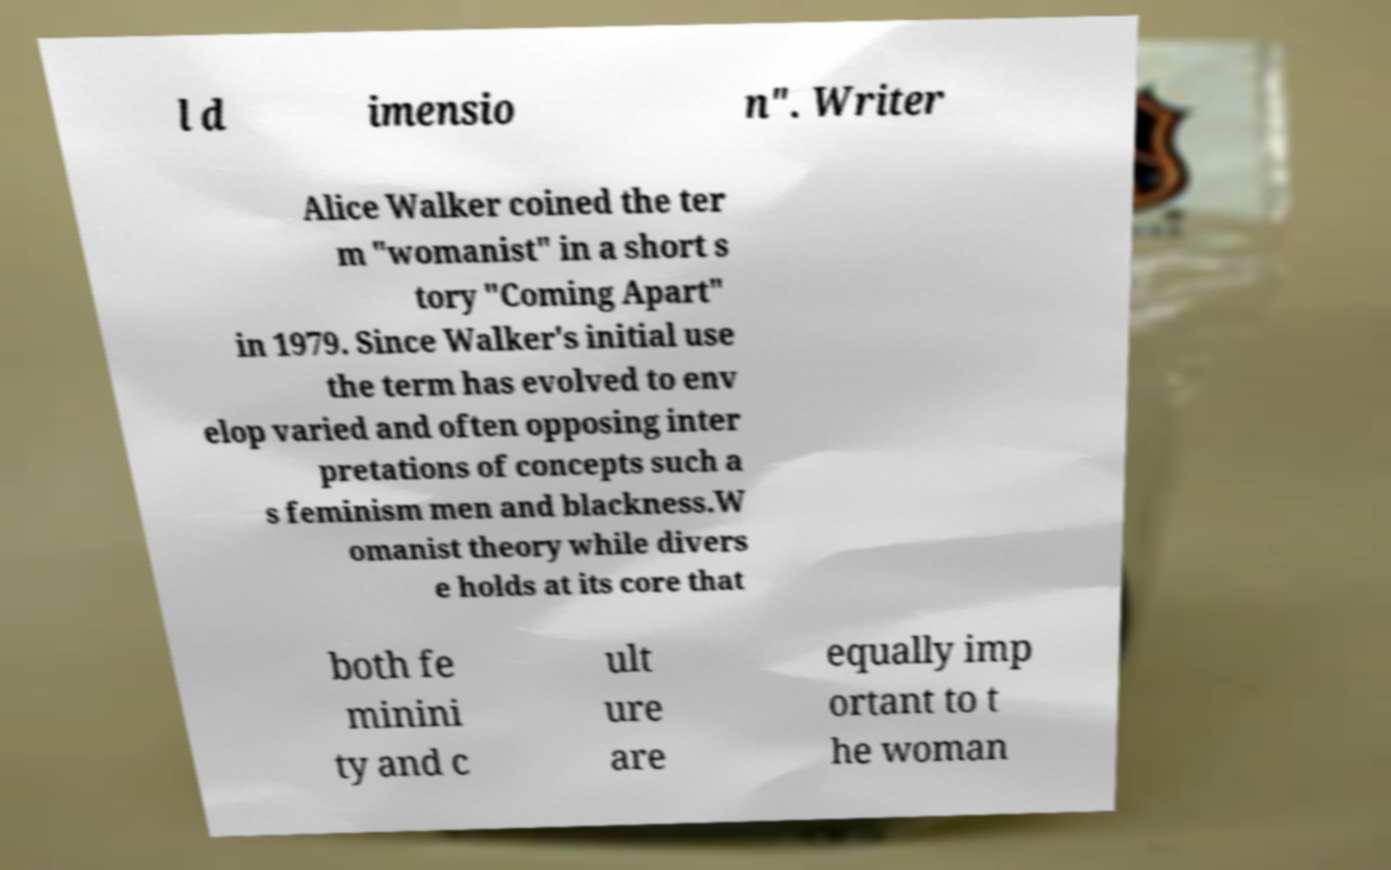Please read and relay the text visible in this image. What does it say? l d imensio n". Writer Alice Walker coined the ter m "womanist" in a short s tory "Coming Apart" in 1979. Since Walker's initial use the term has evolved to env elop varied and often opposing inter pretations of concepts such a s feminism men and blackness.W omanist theory while divers e holds at its core that both fe minini ty and c ult ure are equally imp ortant to t he woman 